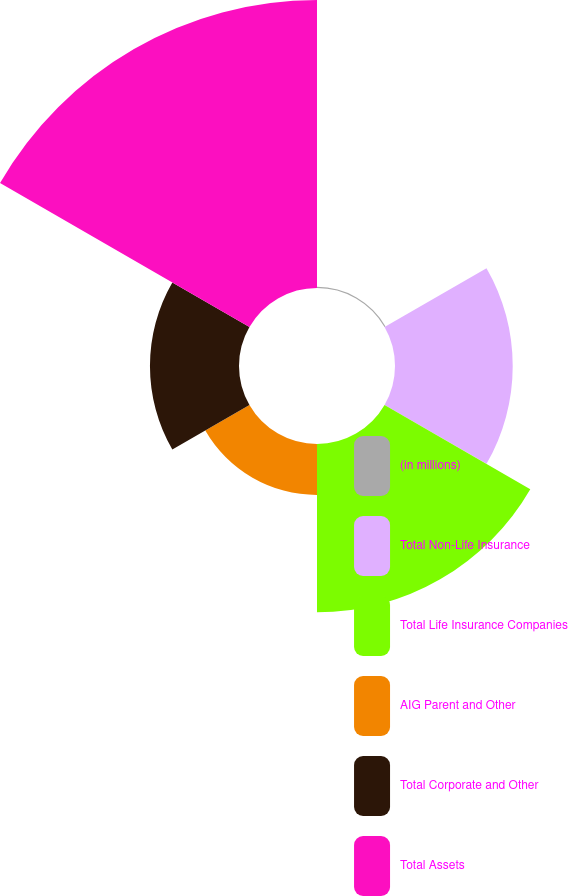<chart> <loc_0><loc_0><loc_500><loc_500><pie_chart><fcel>(in millions)<fcel>Total Non-Life Insurance<fcel>Total Life Insurance Companies<fcel>AIG Parent and Other<fcel>Total Corporate and Other<fcel>Total Assets<nl><fcel>0.16%<fcel>16.46%<fcel>23.53%<fcel>7.13%<fcel>12.45%<fcel>40.27%<nl></chart> 